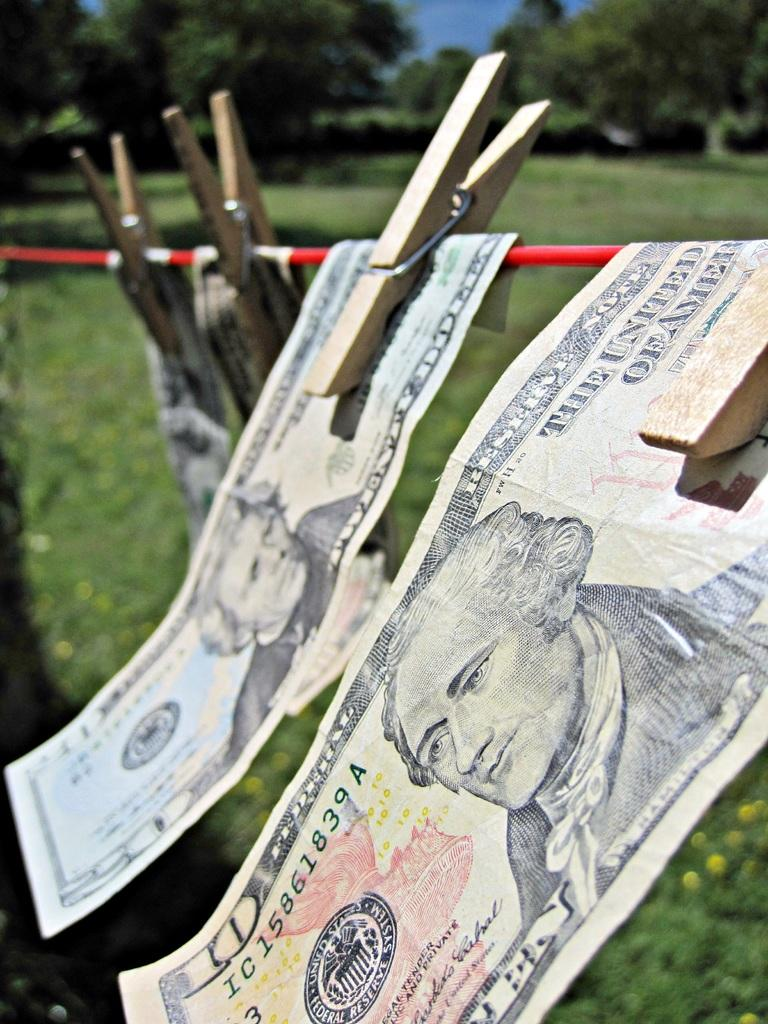What is hanging on the rope in the image? Currency is clipped on a rope in the image. What can be seen in the background of the image? There are trees visible in the background of the image. What is visible at the top of the image? The sky is visible at the top of the image. What type of vegetation is present at the bottom of the image? Flowers and plants are present at the bottom of the image. Can you see a squirrel interacting with the currency in the image? There is no squirrel present in the image, and therefore no interaction with the currency can be observed. Is there a fireman visible in the image? There is no fireman present in the image. 